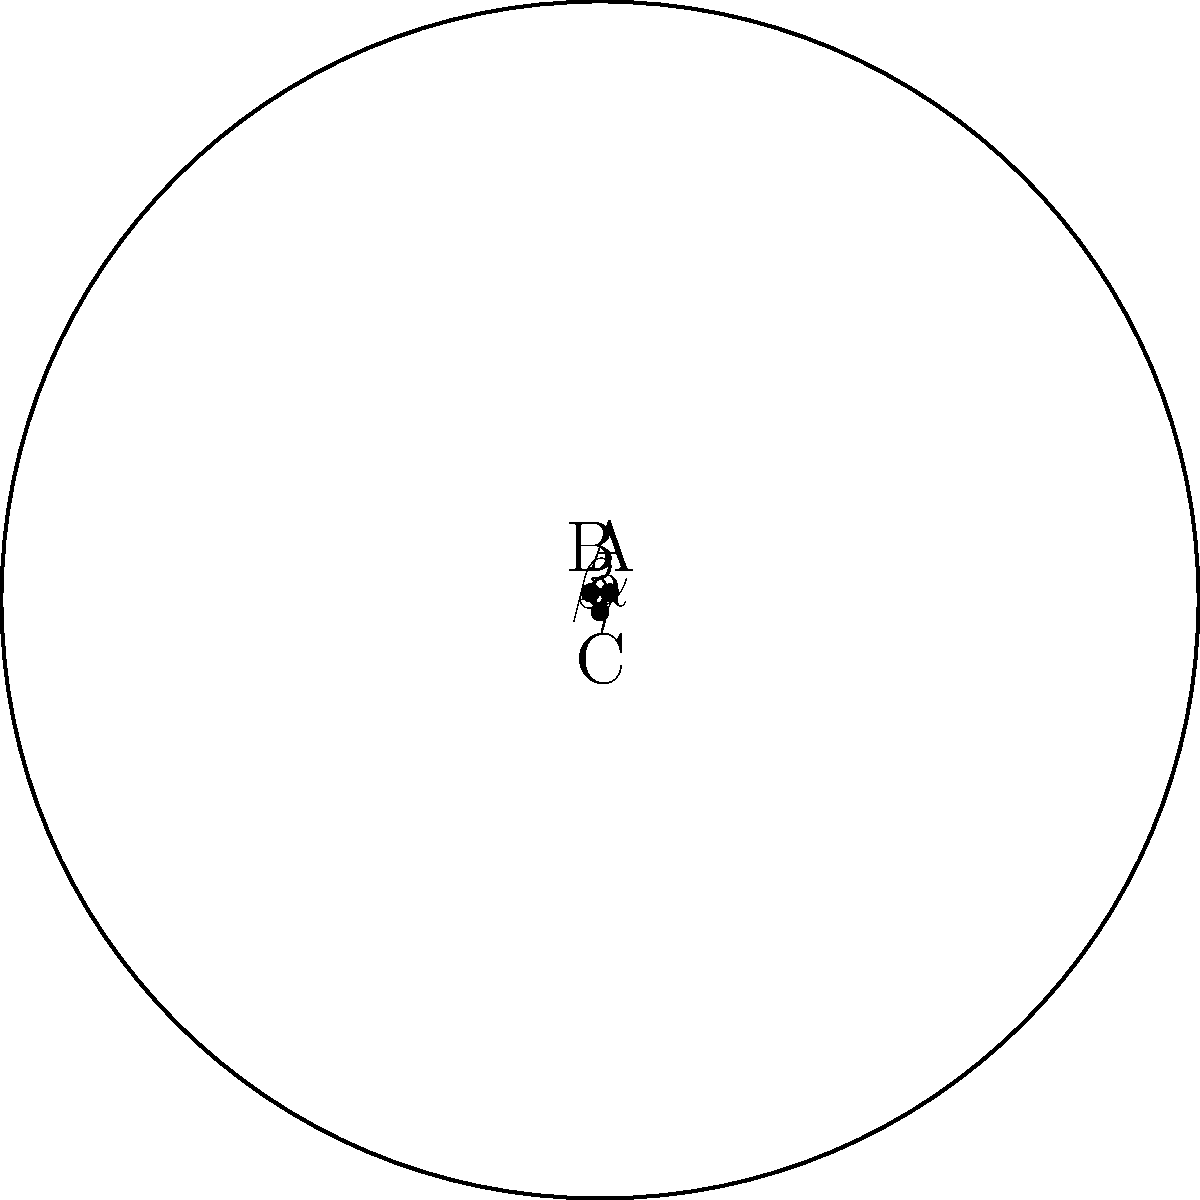In the context of a digital transformation project, you're tasked with explaining a non-Euclidean geometry concept to your team. Consider the triangle ABC drawn on a hyperbolic surface, as shown in the diagram. If the sum of the interior angles ($\alpha + \beta + \gamma$) is 150°, what is the area of this hyperbolic triangle in terms of $R^2$, where R is the radius of curvature of the hyperbolic surface? To solve this problem, let's follow these steps:

1) In hyperbolic geometry, the sum of the angles in a triangle is always less than 180°. The difference between 180° and the actual sum is called the defect.

2) Defect = 180° - (sum of angles)
   Defect = 180° - 150° = 30° = $\frac{\pi}{6}$ radians

3) In hyperbolic geometry, there's a direct relationship between the area of a triangle and its defect. The formula is:

   Area = $R^2 \cdot$ defect

   Where R is the radius of curvature of the hyperbolic surface.

4) Substituting our defect:

   Area = $R^2 \cdot \frac{\pi}{6}$

5) This can be simplified to:

   Area = $\frac{\pi R^2}{6}$

This result shows how non-Euclidean geometry can lead to unexpected relationships between angles and areas, much like how digital transformation can reveal unexpected connections in business processes.
Answer: $\frac{\pi R^2}{6}$ 